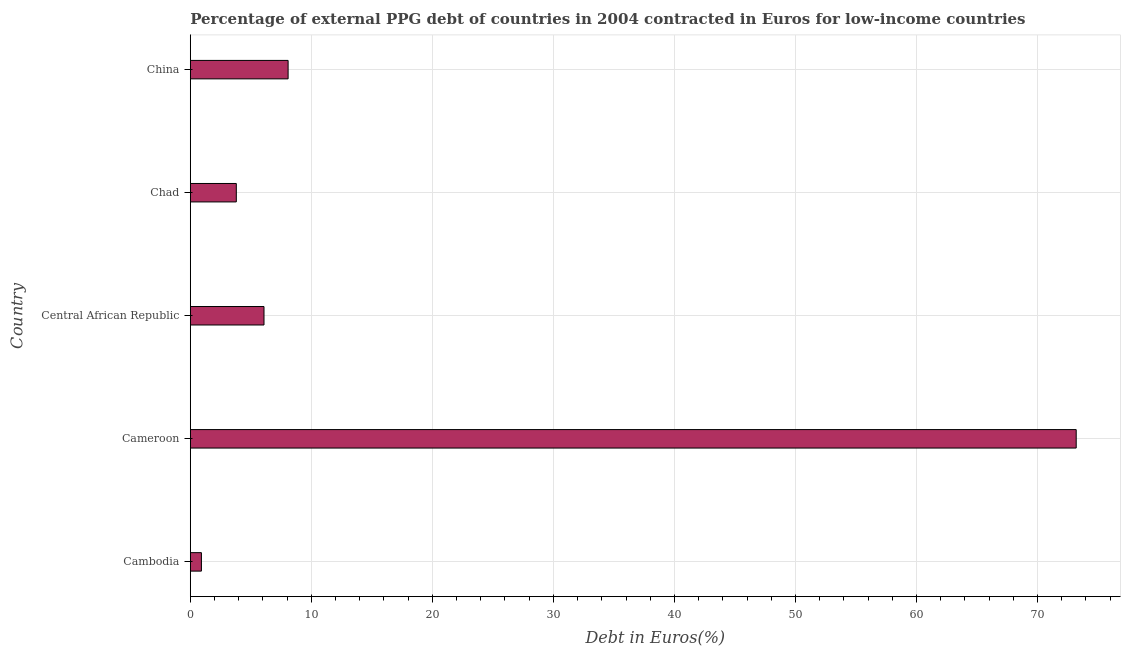What is the title of the graph?
Keep it short and to the point. Percentage of external PPG debt of countries in 2004 contracted in Euros for low-income countries. What is the label or title of the X-axis?
Offer a terse response. Debt in Euros(%). What is the label or title of the Y-axis?
Your response must be concise. Country. What is the currency composition of ppg debt in Central African Republic?
Your answer should be very brief. 6.09. Across all countries, what is the maximum currency composition of ppg debt?
Offer a very short reply. 73.2. Across all countries, what is the minimum currency composition of ppg debt?
Keep it short and to the point. 0.92. In which country was the currency composition of ppg debt maximum?
Your response must be concise. Cameroon. In which country was the currency composition of ppg debt minimum?
Your answer should be very brief. Cambodia. What is the sum of the currency composition of ppg debt?
Give a very brief answer. 92.09. What is the difference between the currency composition of ppg debt in Cameroon and China?
Provide a short and direct response. 65.11. What is the average currency composition of ppg debt per country?
Keep it short and to the point. 18.42. What is the median currency composition of ppg debt?
Keep it short and to the point. 6.09. In how many countries, is the currency composition of ppg debt greater than 20 %?
Offer a very short reply. 1. What is the ratio of the currency composition of ppg debt in Cambodia to that in Chad?
Provide a succinct answer. 0.24. Is the currency composition of ppg debt in Cameroon less than that in Chad?
Provide a succinct answer. No. Is the difference between the currency composition of ppg debt in Cambodia and Central African Republic greater than the difference between any two countries?
Ensure brevity in your answer.  No. What is the difference between the highest and the second highest currency composition of ppg debt?
Your answer should be very brief. 65.11. Is the sum of the currency composition of ppg debt in Cambodia and China greater than the maximum currency composition of ppg debt across all countries?
Give a very brief answer. No. What is the difference between the highest and the lowest currency composition of ppg debt?
Keep it short and to the point. 72.28. Are all the bars in the graph horizontal?
Keep it short and to the point. Yes. Are the values on the major ticks of X-axis written in scientific E-notation?
Give a very brief answer. No. What is the Debt in Euros(%) of Cambodia?
Provide a short and direct response. 0.92. What is the Debt in Euros(%) in Cameroon?
Keep it short and to the point. 73.2. What is the Debt in Euros(%) of Central African Republic?
Ensure brevity in your answer.  6.09. What is the Debt in Euros(%) of Chad?
Make the answer very short. 3.8. What is the Debt in Euros(%) of China?
Offer a very short reply. 8.08. What is the difference between the Debt in Euros(%) in Cambodia and Cameroon?
Your answer should be compact. -72.28. What is the difference between the Debt in Euros(%) in Cambodia and Central African Republic?
Ensure brevity in your answer.  -5.17. What is the difference between the Debt in Euros(%) in Cambodia and Chad?
Give a very brief answer. -2.88. What is the difference between the Debt in Euros(%) in Cambodia and China?
Offer a terse response. -7.16. What is the difference between the Debt in Euros(%) in Cameroon and Central African Republic?
Ensure brevity in your answer.  67.11. What is the difference between the Debt in Euros(%) in Cameroon and Chad?
Your response must be concise. 69.39. What is the difference between the Debt in Euros(%) in Cameroon and China?
Provide a succinct answer. 65.11. What is the difference between the Debt in Euros(%) in Central African Republic and Chad?
Give a very brief answer. 2.29. What is the difference between the Debt in Euros(%) in Central African Republic and China?
Provide a short and direct response. -1.99. What is the difference between the Debt in Euros(%) in Chad and China?
Your response must be concise. -4.28. What is the ratio of the Debt in Euros(%) in Cambodia to that in Cameroon?
Your response must be concise. 0.01. What is the ratio of the Debt in Euros(%) in Cambodia to that in Central African Republic?
Offer a very short reply. 0.15. What is the ratio of the Debt in Euros(%) in Cambodia to that in Chad?
Your answer should be compact. 0.24. What is the ratio of the Debt in Euros(%) in Cambodia to that in China?
Give a very brief answer. 0.11. What is the ratio of the Debt in Euros(%) in Cameroon to that in Central African Republic?
Your answer should be compact. 12.02. What is the ratio of the Debt in Euros(%) in Cameroon to that in Chad?
Offer a terse response. 19.25. What is the ratio of the Debt in Euros(%) in Cameroon to that in China?
Provide a short and direct response. 9.06. What is the ratio of the Debt in Euros(%) in Central African Republic to that in Chad?
Your answer should be very brief. 1.6. What is the ratio of the Debt in Euros(%) in Central African Republic to that in China?
Give a very brief answer. 0.75. What is the ratio of the Debt in Euros(%) in Chad to that in China?
Provide a short and direct response. 0.47. 